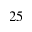<formula> <loc_0><loc_0><loc_500><loc_500>2 5</formula> 